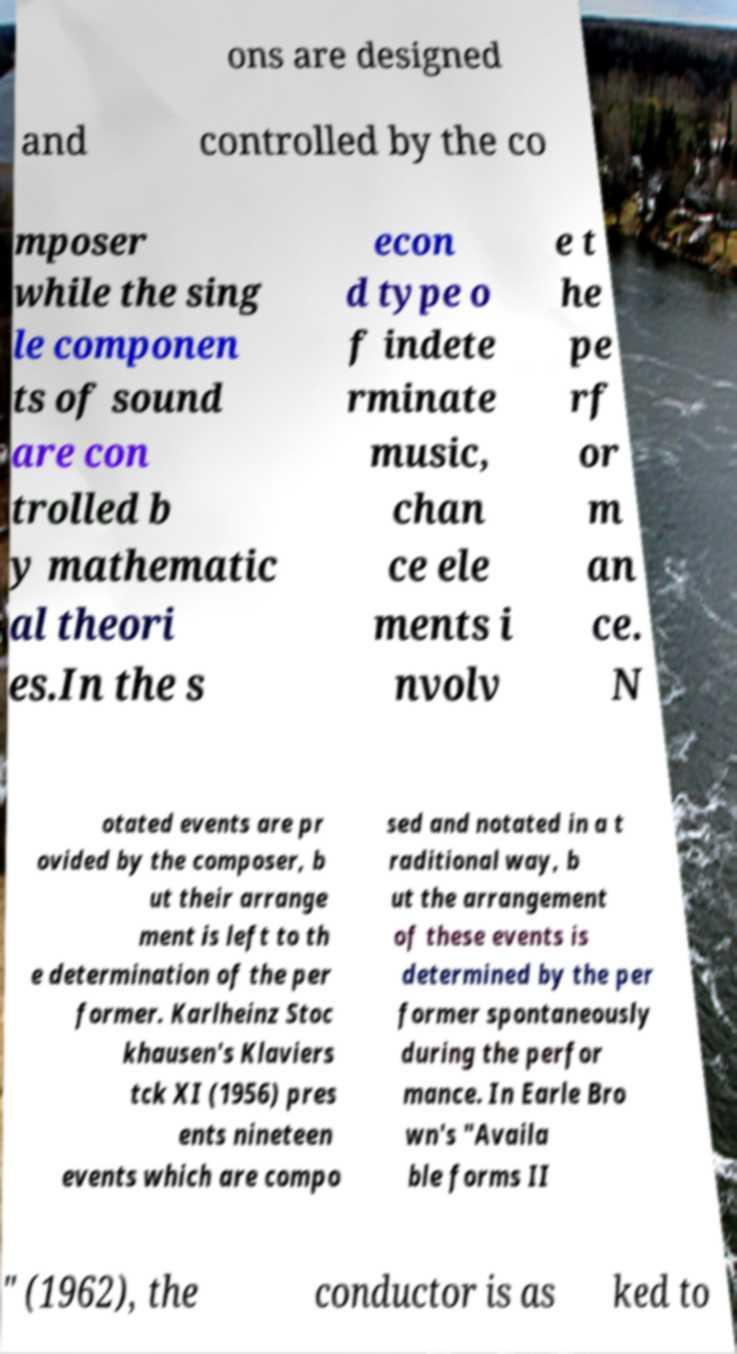What messages or text are displayed in this image? I need them in a readable, typed format. ons are designed and controlled by the co mposer while the sing le componen ts of sound are con trolled b y mathematic al theori es.In the s econ d type o f indete rminate music, chan ce ele ments i nvolv e t he pe rf or m an ce. N otated events are pr ovided by the composer, b ut their arrange ment is left to th e determination of the per former. Karlheinz Stoc khausen's Klaviers tck XI (1956) pres ents nineteen events which are compo sed and notated in a t raditional way, b ut the arrangement of these events is determined by the per former spontaneously during the perfor mance. In Earle Bro wn's "Availa ble forms II " (1962), the conductor is as ked to 